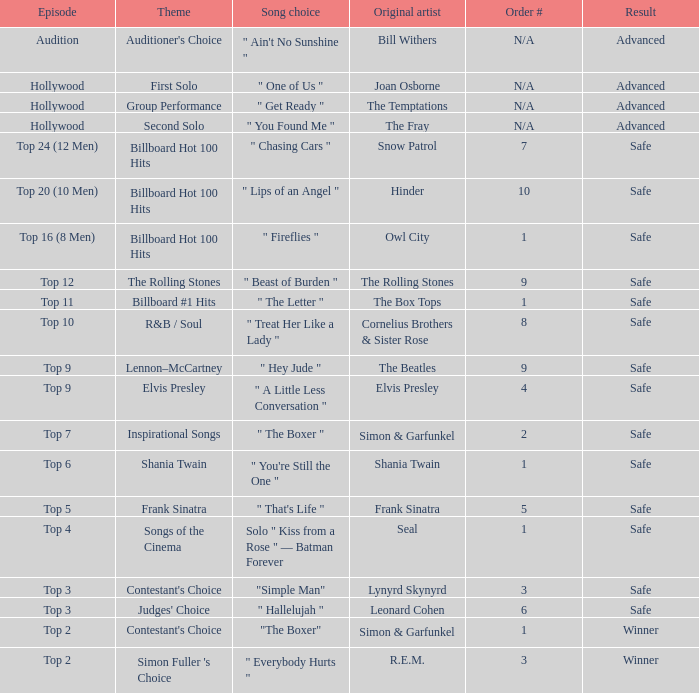Which themes can be found in the song "one of us"? First Solo. 